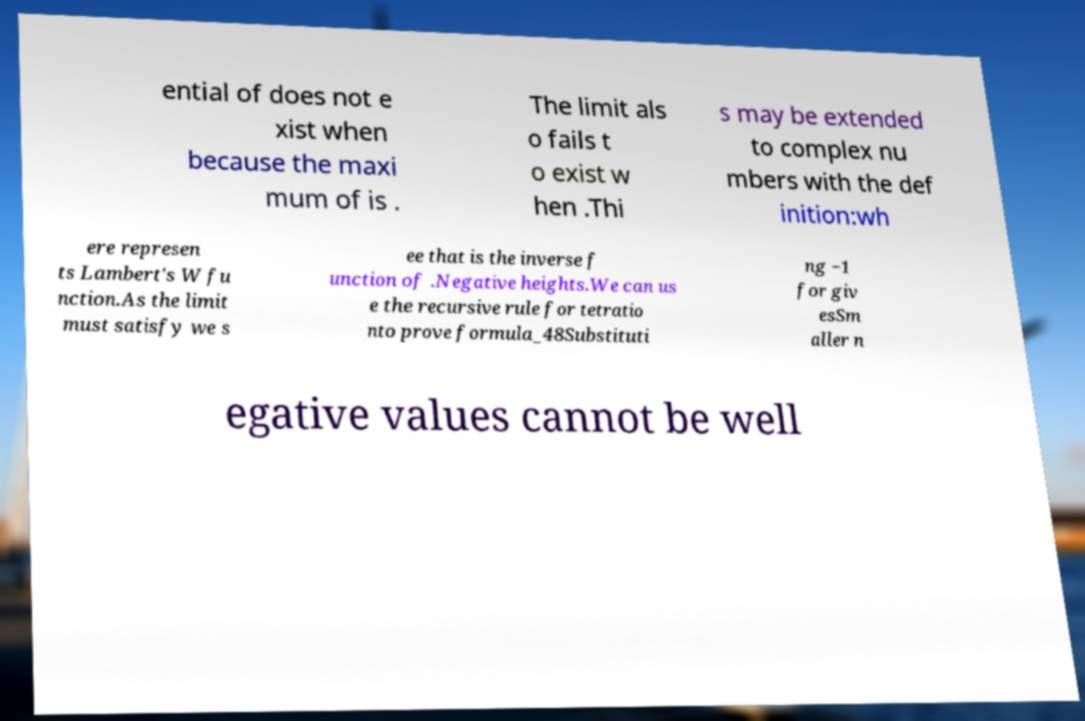Could you extract and type out the text from this image? ential of does not e xist when because the maxi mum of is . The limit als o fails t o exist w hen .Thi s may be extended to complex nu mbers with the def inition:wh ere represen ts Lambert's W fu nction.As the limit must satisfy we s ee that is the inverse f unction of .Negative heights.We can us e the recursive rule for tetratio nto prove formula_48Substituti ng −1 for giv esSm aller n egative values cannot be well 